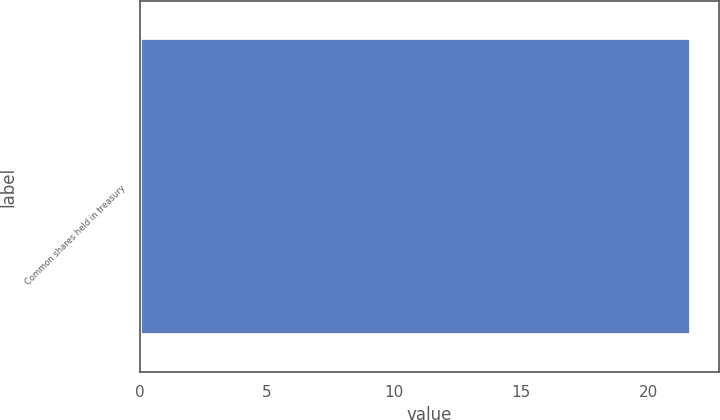<chart> <loc_0><loc_0><loc_500><loc_500><bar_chart><fcel>Common shares held in treasury<nl><fcel>21.7<nl></chart> 